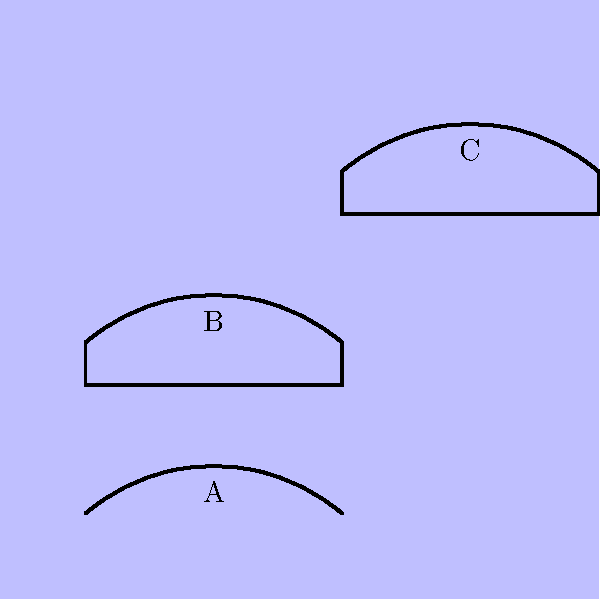In the aerial view of traditional Palauan canoes shown above, which type of canoe is represented by label B? To answer this question, we need to analyze the characteristics of the three canoe types shown in the aerial view and compare them to known features of traditional Palauan canoes:

1. Canoe A: This is the smallest canoe, with a simple, narrow design and no visible outrigger. This matches the description of a "kaep," which is a small fishing canoe.

2. Canoe B: This canoe has a wider body than A and appears to have an outrigger attached. Its size and shape are consistent with a "kabekel," which is a medium-sized outrigger canoe used for fishing and transportation between islands.

3. Canoe C: This is the largest canoe shown, with a wide body and likely an outrigger (though not clearly visible in this view). Its size suggests it could be a "btang," which is a large ocean-going canoe used for long-distance voyages.

Based on these observations, the canoe labeled B most closely matches the characteristics of a kabekel, a medium-sized outrigger canoe commonly used in Palau.
Answer: Kabekel 